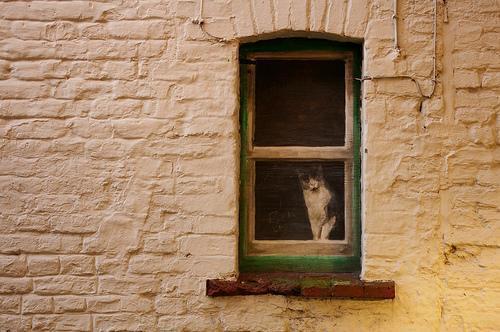How many cats are in the window?
Give a very brief answer. 1. How many windows are pictured?
Give a very brief answer. 1. 